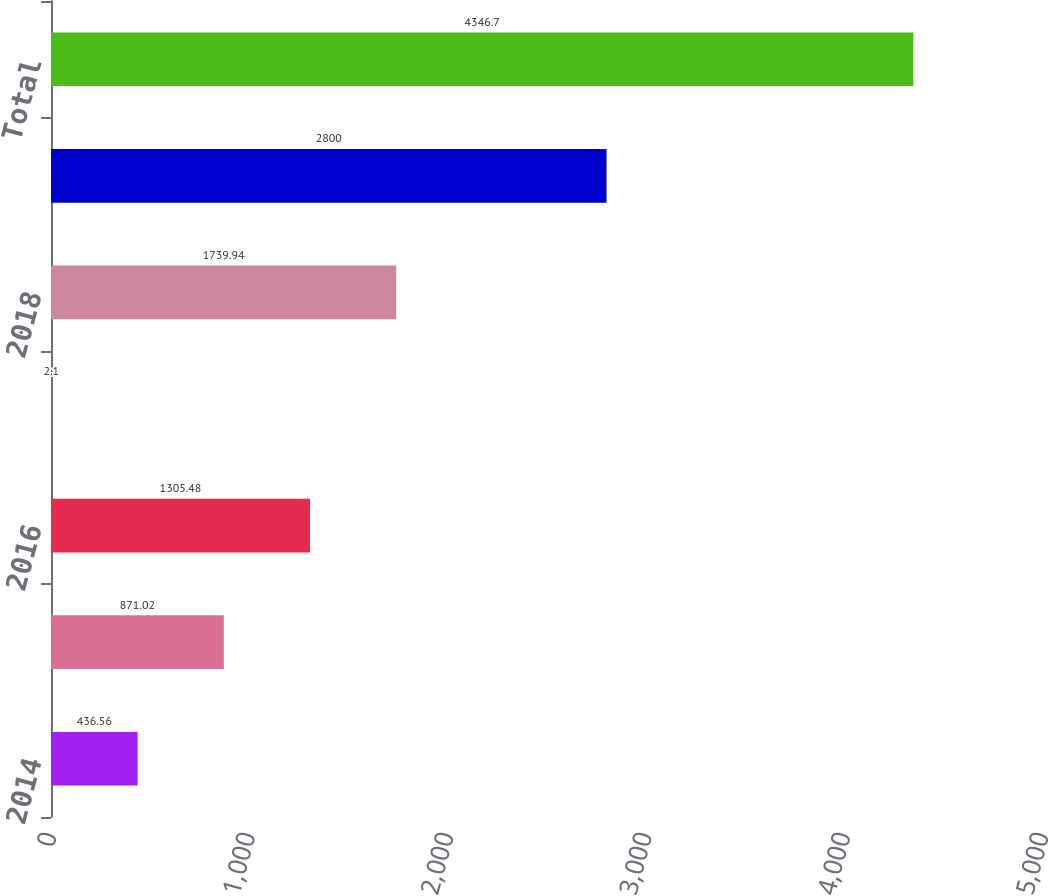Convert chart to OTSL. <chart><loc_0><loc_0><loc_500><loc_500><bar_chart><fcel>2014<fcel>2015<fcel>2016<fcel>2017<fcel>2018<fcel>Thereafter<fcel>Total<nl><fcel>436.56<fcel>871.02<fcel>1305.48<fcel>2.1<fcel>1739.94<fcel>2800<fcel>4346.7<nl></chart> 